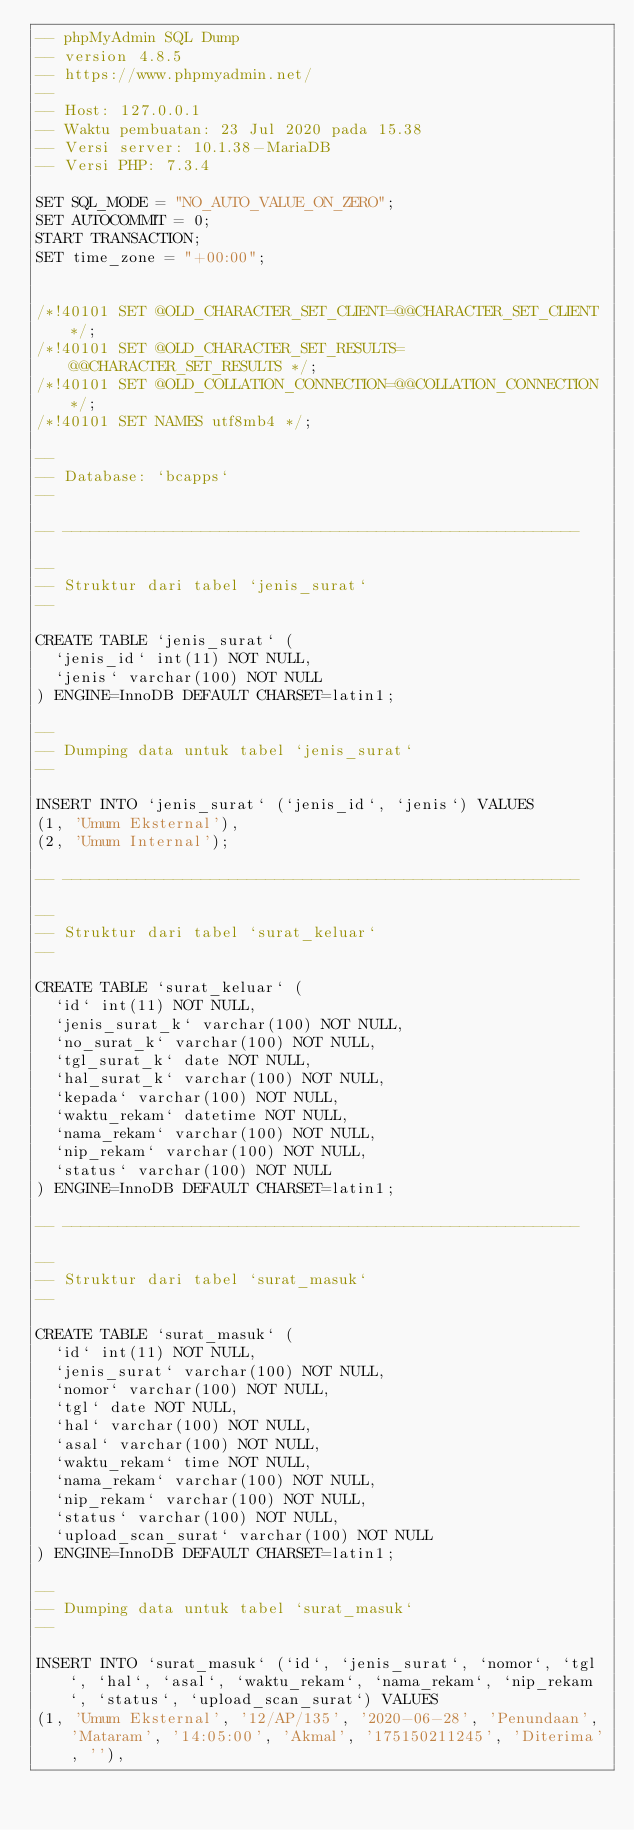Convert code to text. <code><loc_0><loc_0><loc_500><loc_500><_SQL_>-- phpMyAdmin SQL Dump
-- version 4.8.5
-- https://www.phpmyadmin.net/
--
-- Host: 127.0.0.1
-- Waktu pembuatan: 23 Jul 2020 pada 15.38
-- Versi server: 10.1.38-MariaDB
-- Versi PHP: 7.3.4

SET SQL_MODE = "NO_AUTO_VALUE_ON_ZERO";
SET AUTOCOMMIT = 0;
START TRANSACTION;
SET time_zone = "+00:00";


/*!40101 SET @OLD_CHARACTER_SET_CLIENT=@@CHARACTER_SET_CLIENT */;
/*!40101 SET @OLD_CHARACTER_SET_RESULTS=@@CHARACTER_SET_RESULTS */;
/*!40101 SET @OLD_COLLATION_CONNECTION=@@COLLATION_CONNECTION */;
/*!40101 SET NAMES utf8mb4 */;

--
-- Database: `bcapps`
--

-- --------------------------------------------------------

--
-- Struktur dari tabel `jenis_surat`
--

CREATE TABLE `jenis_surat` (
  `jenis_id` int(11) NOT NULL,
  `jenis` varchar(100) NOT NULL
) ENGINE=InnoDB DEFAULT CHARSET=latin1;

--
-- Dumping data untuk tabel `jenis_surat`
--

INSERT INTO `jenis_surat` (`jenis_id`, `jenis`) VALUES
(1, 'Umum Eksternal'),
(2, 'Umum Internal');

-- --------------------------------------------------------

--
-- Struktur dari tabel `surat_keluar`
--

CREATE TABLE `surat_keluar` (
  `id` int(11) NOT NULL,
  `jenis_surat_k` varchar(100) NOT NULL,
  `no_surat_k` varchar(100) NOT NULL,
  `tgl_surat_k` date NOT NULL,
  `hal_surat_k` varchar(100) NOT NULL,
  `kepada` varchar(100) NOT NULL,
  `waktu_rekam` datetime NOT NULL,
  `nama_rekam` varchar(100) NOT NULL,
  `nip_rekam` varchar(100) NOT NULL,
  `status` varchar(100) NOT NULL
) ENGINE=InnoDB DEFAULT CHARSET=latin1;

-- --------------------------------------------------------

--
-- Struktur dari tabel `surat_masuk`
--

CREATE TABLE `surat_masuk` (
  `id` int(11) NOT NULL,
  `jenis_surat` varchar(100) NOT NULL,
  `nomor` varchar(100) NOT NULL,
  `tgl` date NOT NULL,
  `hal` varchar(100) NOT NULL,
  `asal` varchar(100) NOT NULL,
  `waktu_rekam` time NOT NULL,
  `nama_rekam` varchar(100) NOT NULL,
  `nip_rekam` varchar(100) NOT NULL,
  `status` varchar(100) NOT NULL,
  `upload_scan_surat` varchar(100) NOT NULL
) ENGINE=InnoDB DEFAULT CHARSET=latin1;

--
-- Dumping data untuk tabel `surat_masuk`
--

INSERT INTO `surat_masuk` (`id`, `jenis_surat`, `nomor`, `tgl`, `hal`, `asal`, `waktu_rekam`, `nama_rekam`, `nip_rekam`, `status`, `upload_scan_surat`) VALUES
(1, 'Umum Eksternal', '12/AP/135', '2020-06-28', 'Penundaan', 'Mataram', '14:05:00', 'Akmal', '175150211245', 'Diterima', ''),</code> 